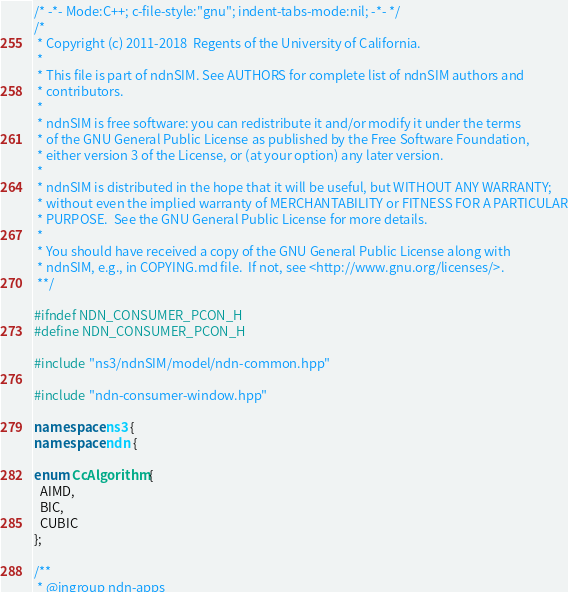Convert code to text. <code><loc_0><loc_0><loc_500><loc_500><_C++_>/* -*- Mode:C++; c-file-style:"gnu"; indent-tabs-mode:nil; -*- */
/*
 * Copyright (c) 2011-2018  Regents of the University of California.
 *
 * This file is part of ndnSIM. See AUTHORS for complete list of ndnSIM authors and
 * contributors.
 *
 * ndnSIM is free software: you can redistribute it and/or modify it under the terms
 * of the GNU General Public License as published by the Free Software Foundation,
 * either version 3 of the License, or (at your option) any later version.
 *
 * ndnSIM is distributed in the hope that it will be useful, but WITHOUT ANY WARRANTY;
 * without even the implied warranty of MERCHANTABILITY or FITNESS FOR A PARTICULAR
 * PURPOSE.  See the GNU General Public License for more details.
 *
 * You should have received a copy of the GNU General Public License along with
 * ndnSIM, e.g., in COPYING.md file.  If not, see <http://www.gnu.org/licenses/>.
 **/

#ifndef NDN_CONSUMER_PCON_H
#define NDN_CONSUMER_PCON_H

#include "ns3/ndnSIM/model/ndn-common.hpp"

#include "ndn-consumer-window.hpp"

namespace ns3 {
namespace ndn {

enum CcAlgorithm {
  AIMD,
  BIC,
  CUBIC
};

/**
 * @ingroup ndn-apps</code> 